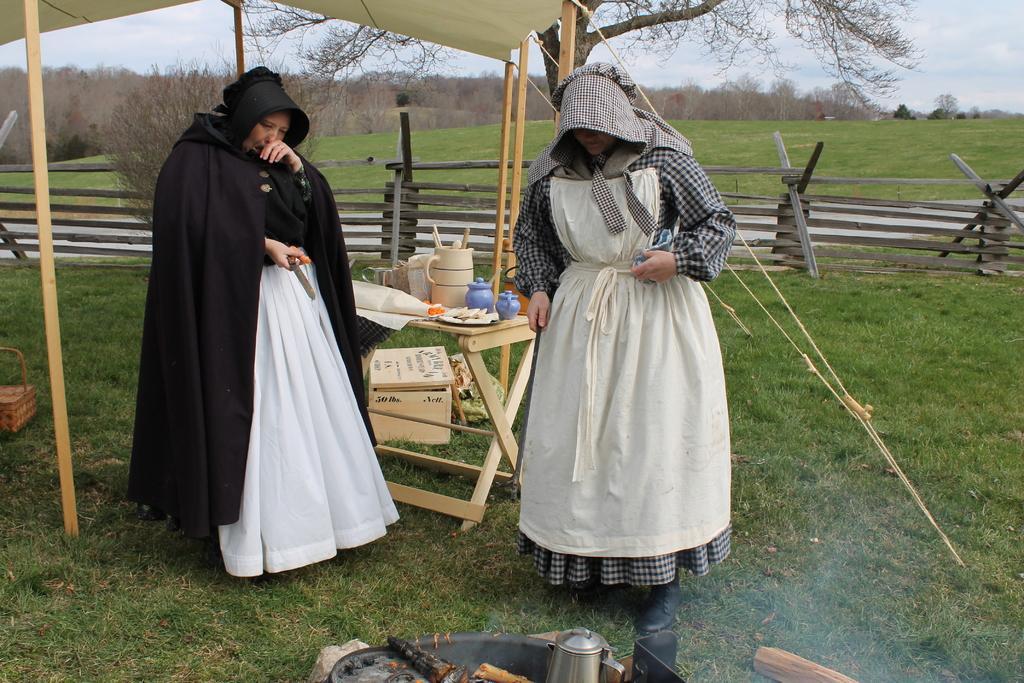How would you summarize this image in a sentence or two? In this picture we can see two persons are standing on the ground. This is table. On the table there is a plate and a jar. On the background we can see some trees. This is grass and there is a sky. 